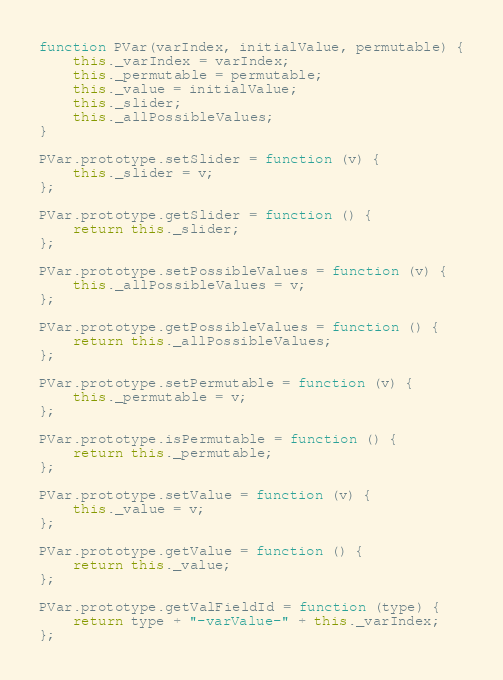Convert code to text. <code><loc_0><loc_0><loc_500><loc_500><_JavaScript_>function PVar(varIndex, initialValue, permutable) {
	this._varIndex = varIndex;
	this._permutable = permutable;
	this._value = initialValue;
	this._slider;
	this._allPossibleValues;
}

PVar.prototype.setSlider = function (v) {
	this._slider = v;
};

PVar.prototype.getSlider = function () {
	return this._slider;
};

PVar.prototype.setPossibleValues = function (v) {
	this._allPossibleValues = v;
};

PVar.prototype.getPossibleValues = function () {
	return this._allPossibleValues;
};

PVar.prototype.setPermutable = function (v) {
	this._permutable = v;
};

PVar.prototype.isPermutable = function () {
	return this._permutable;
};

PVar.prototype.setValue = function (v) {
	this._value = v;
};

PVar.prototype.getValue = function () {
	return this._value;
};

PVar.prototype.getValFieldId = function (type) {
	return type + "-varValue-" + this._varIndex;
};
</code> 